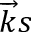<formula> <loc_0><loc_0><loc_500><loc_500>\overrightarrow { k } s</formula> 